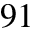Convert formula to latex. <formula><loc_0><loc_0><loc_500><loc_500>^ { 9 1 }</formula> 